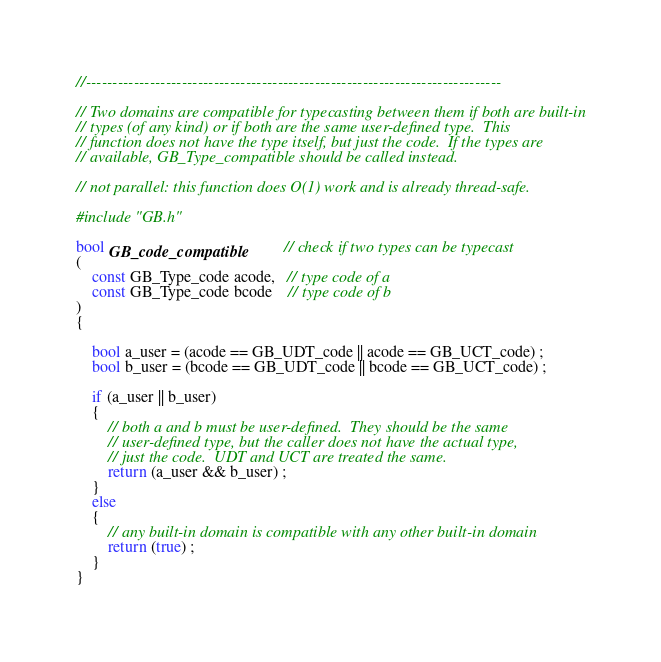Convert code to text. <code><loc_0><loc_0><loc_500><loc_500><_C_>
//------------------------------------------------------------------------------

// Two domains are compatible for typecasting between them if both are built-in
// types (of any kind) or if both are the same user-defined type.  This
// function does not have the type itself, but just the code.  If the types are
// available, GB_Type_compatible should be called instead.

// not parallel: this function does O(1) work and is already thread-safe.

#include "GB.h"

bool GB_code_compatible         // check if two types can be typecast
(
    const GB_Type_code acode,   // type code of a
    const GB_Type_code bcode    // type code of b
)
{

    bool a_user = (acode == GB_UDT_code || acode == GB_UCT_code) ;
    bool b_user = (bcode == GB_UDT_code || bcode == GB_UCT_code) ;

    if (a_user || b_user)
    { 
        // both a and b must be user-defined.  They should be the same
        // user-defined type, but the caller does not have the actual type,
        // just the code.  UDT and UCT are treated the same.
        return (a_user && b_user) ;
    }
    else
    { 
        // any built-in domain is compatible with any other built-in domain
        return (true) ;
    }
}

</code> 